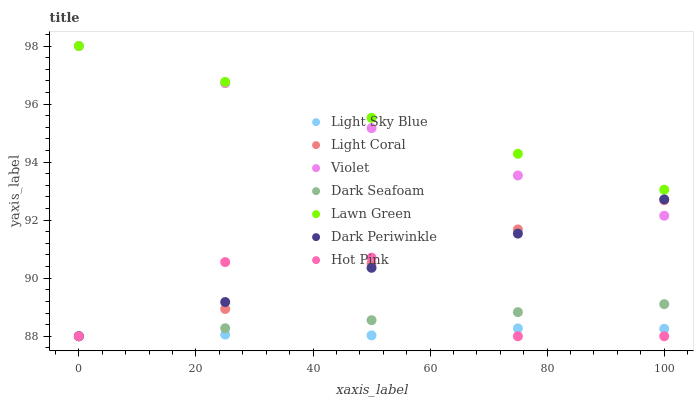Does Light Sky Blue have the minimum area under the curve?
Answer yes or no. Yes. Does Lawn Green have the maximum area under the curve?
Answer yes or no. Yes. Does Hot Pink have the minimum area under the curve?
Answer yes or no. No. Does Hot Pink have the maximum area under the curve?
Answer yes or no. No. Is Dark Periwinkle the smoothest?
Answer yes or no. Yes. Is Hot Pink the roughest?
Answer yes or no. Yes. Is Light Coral the smoothest?
Answer yes or no. No. Is Light Coral the roughest?
Answer yes or no. No. Does Hot Pink have the lowest value?
Answer yes or no. Yes. Does Violet have the lowest value?
Answer yes or no. No. Does Violet have the highest value?
Answer yes or no. Yes. Does Hot Pink have the highest value?
Answer yes or no. No. Is Hot Pink less than Violet?
Answer yes or no. Yes. Is Lawn Green greater than Dark Seafoam?
Answer yes or no. Yes. Does Dark Periwinkle intersect Hot Pink?
Answer yes or no. Yes. Is Dark Periwinkle less than Hot Pink?
Answer yes or no. No. Is Dark Periwinkle greater than Hot Pink?
Answer yes or no. No. Does Hot Pink intersect Violet?
Answer yes or no. No. 